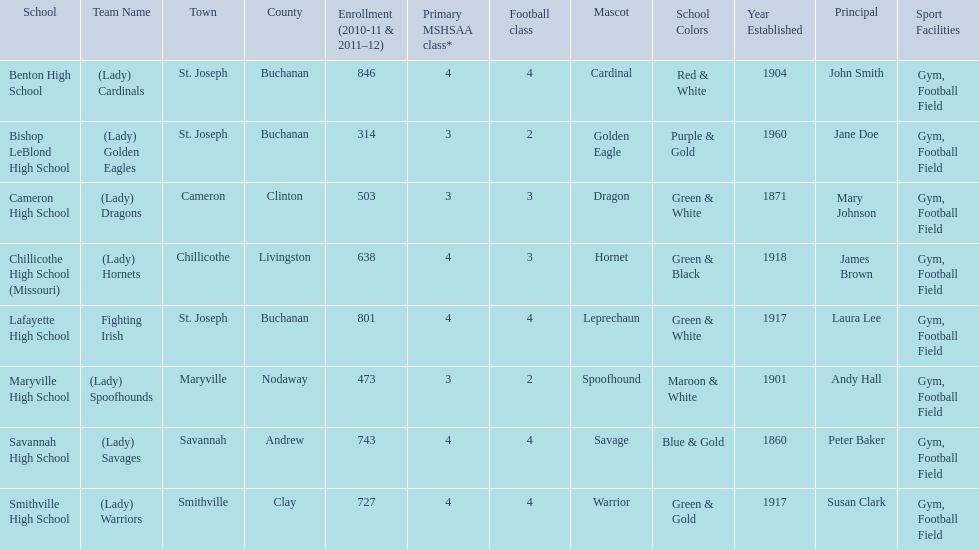What are the names of the schools? Benton High School, Bishop LeBlond High School, Cameron High School, Chillicothe High School (Missouri), Lafayette High School, Maryville High School, Savannah High School, Smithville High School. Of those, which had a total enrollment of less than 500? Bishop LeBlond High School, Maryville High School. And of those, which had the lowest enrollment? Bishop LeBlond High School. 